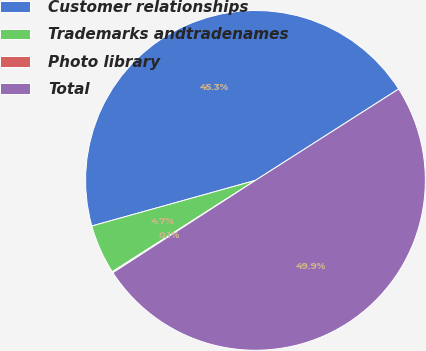Convert chart. <chart><loc_0><loc_0><loc_500><loc_500><pie_chart><fcel>Customer relationships<fcel>Trademarks andtradenames<fcel>Photo library<fcel>Total<nl><fcel>45.29%<fcel>4.71%<fcel>0.11%<fcel>49.89%<nl></chart> 